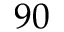Convert formula to latex. <formula><loc_0><loc_0><loc_500><loc_500>9 0</formula> 